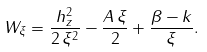<formula> <loc_0><loc_0><loc_500><loc_500>W _ { \xi } = \frac { h _ { z } ^ { 2 } } { 2 \, \xi ^ { 2 } } - \frac { A \, \xi } { 2 } + \frac { \beta - k } { \xi } .</formula> 